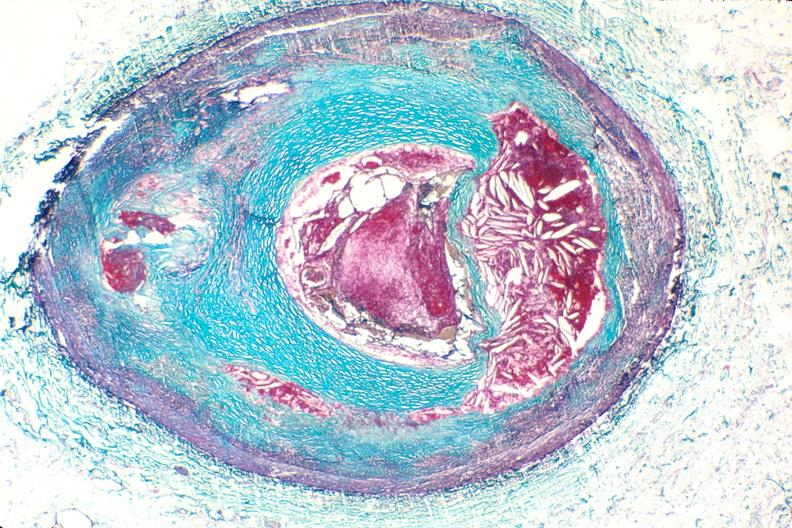what does this image show?
Answer the question using a single word or phrase. Right coronary artery 